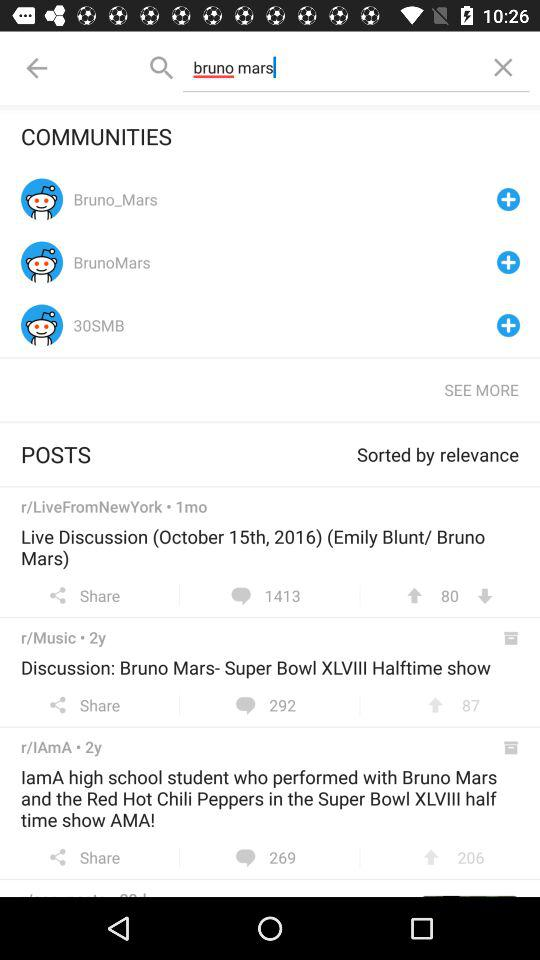How many likes on discussion;bruno-mars super bowl?
When the provided information is insufficient, respond with <no answer>. <no answer> 